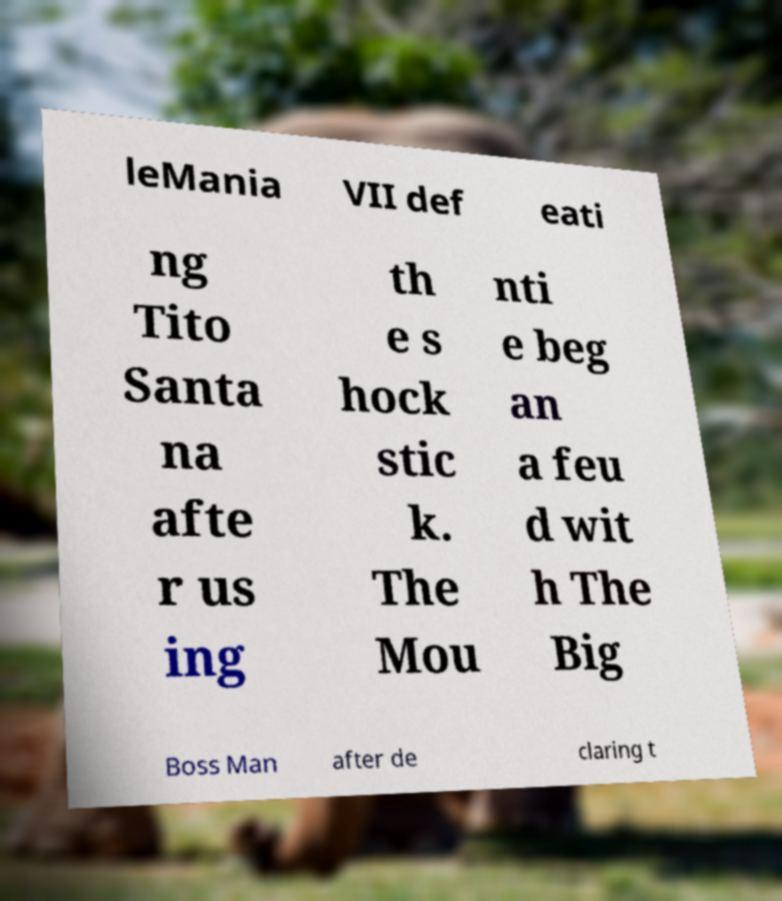Can you accurately transcribe the text from the provided image for me? leMania VII def eati ng Tito Santa na afte r us ing th e s hock stic k. The Mou nti e beg an a feu d wit h The Big Boss Man after de claring t 